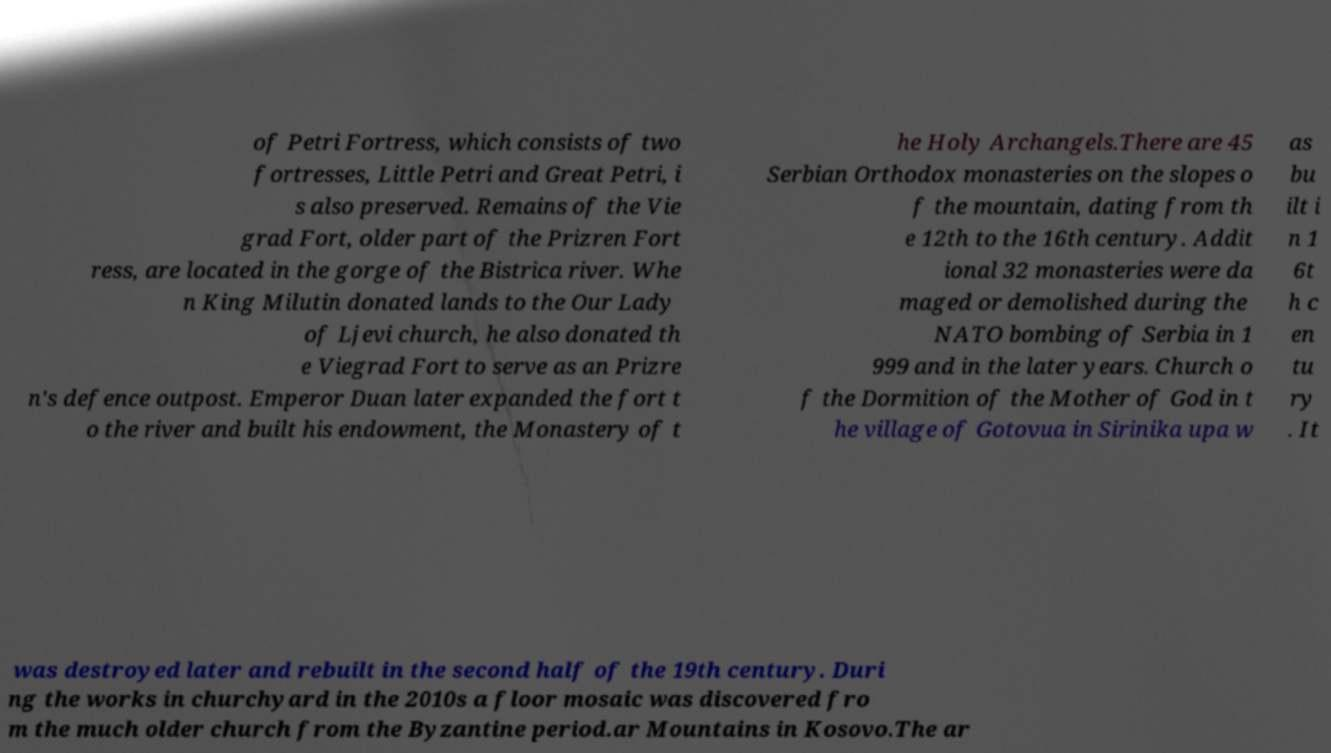What messages or text are displayed in this image? I need them in a readable, typed format. of Petri Fortress, which consists of two fortresses, Little Petri and Great Petri, i s also preserved. Remains of the Vie grad Fort, older part of the Prizren Fort ress, are located in the gorge of the Bistrica river. Whe n King Milutin donated lands to the Our Lady of Ljevi church, he also donated th e Viegrad Fort to serve as an Prizre n's defence outpost. Emperor Duan later expanded the fort t o the river and built his endowment, the Monastery of t he Holy Archangels.There are 45 Serbian Orthodox monasteries on the slopes o f the mountain, dating from th e 12th to the 16th century. Addit ional 32 monasteries were da maged or demolished during the NATO bombing of Serbia in 1 999 and in the later years. Church o f the Dormition of the Mother of God in t he village of Gotovua in Sirinika upa w as bu ilt i n 1 6t h c en tu ry . It was destroyed later and rebuilt in the second half of the 19th century. Duri ng the works in churchyard in the 2010s a floor mosaic was discovered fro m the much older church from the Byzantine period.ar Mountains in Kosovo.The ar 